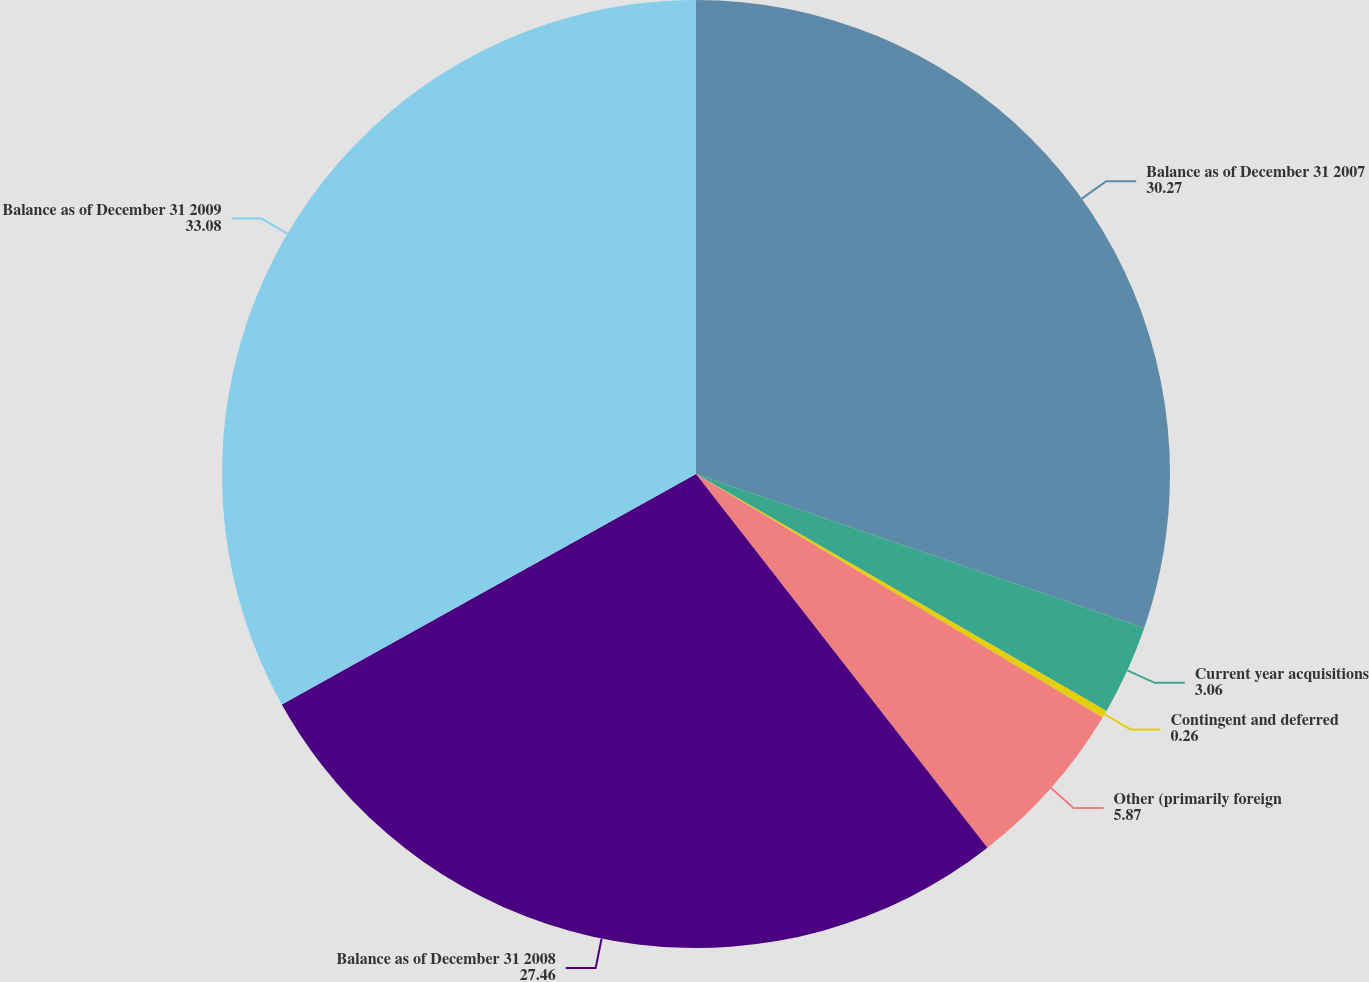<chart> <loc_0><loc_0><loc_500><loc_500><pie_chart><fcel>Balance as of December 31 2007<fcel>Current year acquisitions<fcel>Contingent and deferred<fcel>Other (primarily foreign<fcel>Balance as of December 31 2008<fcel>Balance as of December 31 2009<nl><fcel>30.27%<fcel>3.06%<fcel>0.26%<fcel>5.87%<fcel>27.46%<fcel>33.08%<nl></chart> 